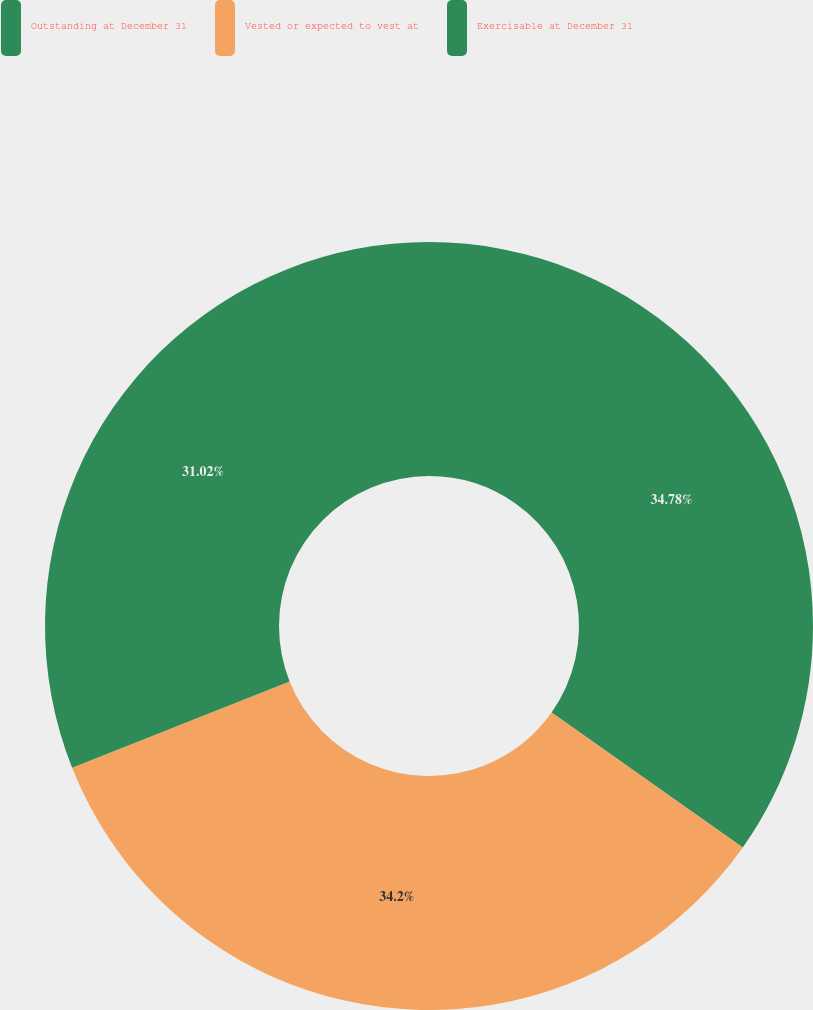Convert chart to OTSL. <chart><loc_0><loc_0><loc_500><loc_500><pie_chart><fcel>Outstanding at December 31<fcel>Vested or expected to vest at<fcel>Exercisable at December 31<nl><fcel>34.78%<fcel>34.2%<fcel>31.02%<nl></chart> 